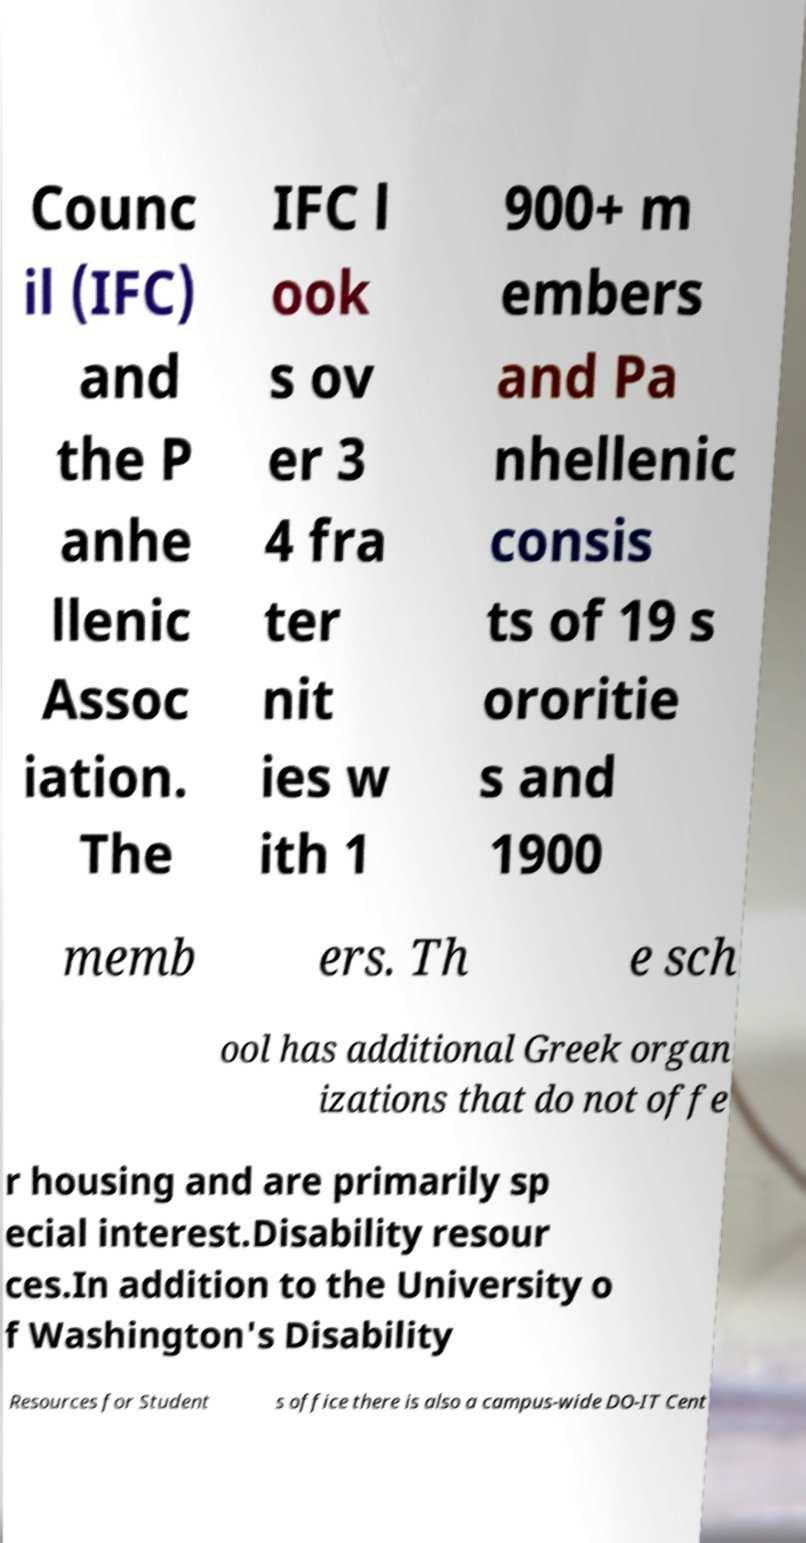Please identify and transcribe the text found in this image. Counc il (IFC) and the P anhe llenic Assoc iation. The IFC l ook s ov er 3 4 fra ter nit ies w ith 1 900+ m embers and Pa nhellenic consis ts of 19 s ororitie s and 1900 memb ers. Th e sch ool has additional Greek organ izations that do not offe r housing and are primarily sp ecial interest.Disability resour ces.In addition to the University o f Washington's Disability Resources for Student s office there is also a campus-wide DO-IT Cent 